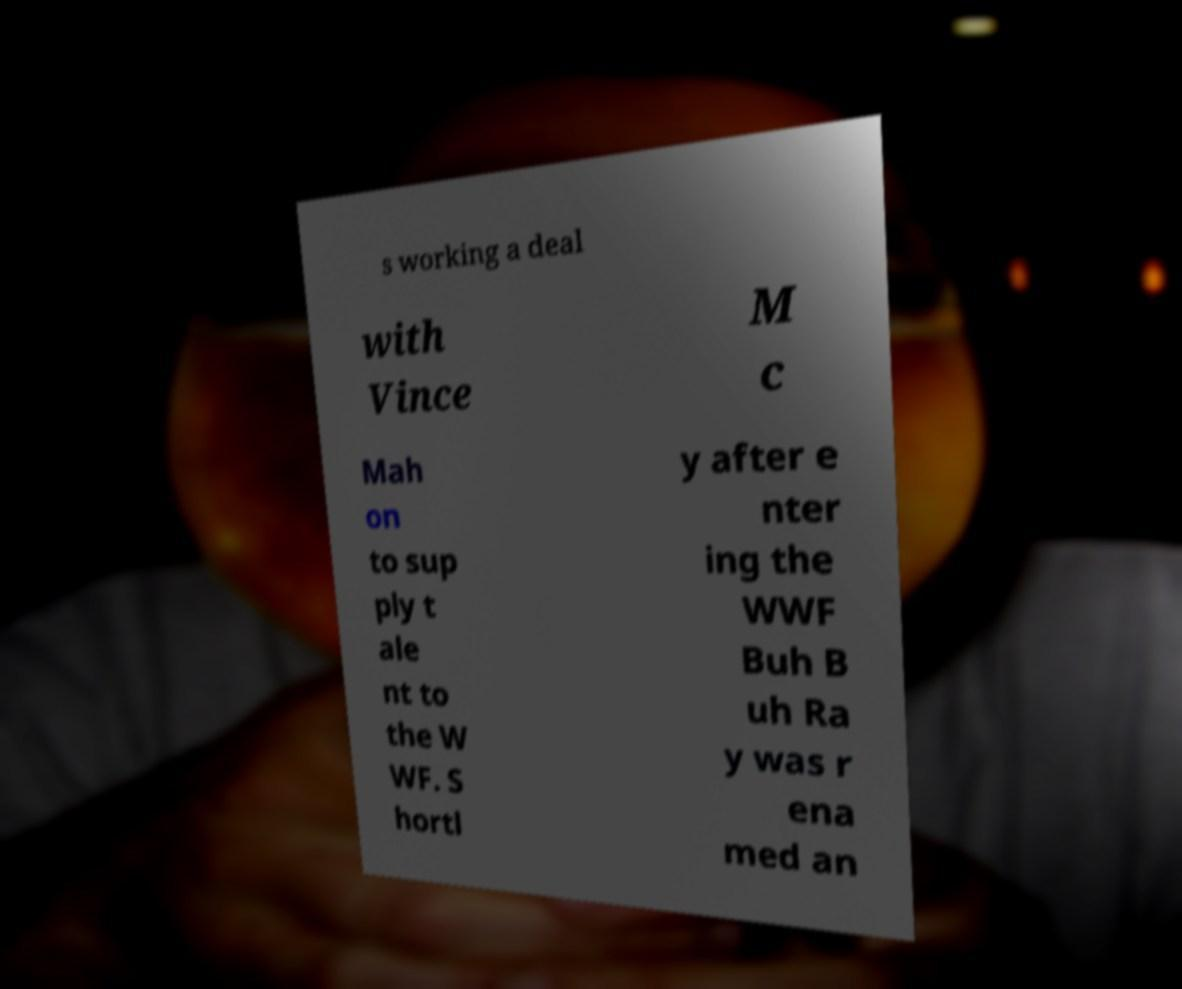There's text embedded in this image that I need extracted. Can you transcribe it verbatim? s working a deal with Vince M c Mah on to sup ply t ale nt to the W WF. S hortl y after e nter ing the WWF Buh B uh Ra y was r ena med an 